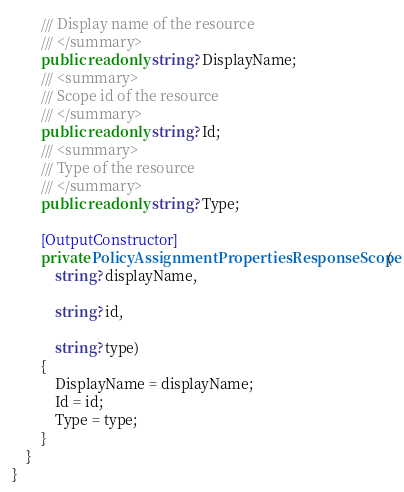<code> <loc_0><loc_0><loc_500><loc_500><_C#_>        /// Display name of the resource
        /// </summary>
        public readonly string? DisplayName;
        /// <summary>
        /// Scope id of the resource
        /// </summary>
        public readonly string? Id;
        /// <summary>
        /// Type of the resource
        /// </summary>
        public readonly string? Type;

        [OutputConstructor]
        private PolicyAssignmentPropertiesResponseScope(
            string? displayName,

            string? id,

            string? type)
        {
            DisplayName = displayName;
            Id = id;
            Type = type;
        }
    }
}
</code> 